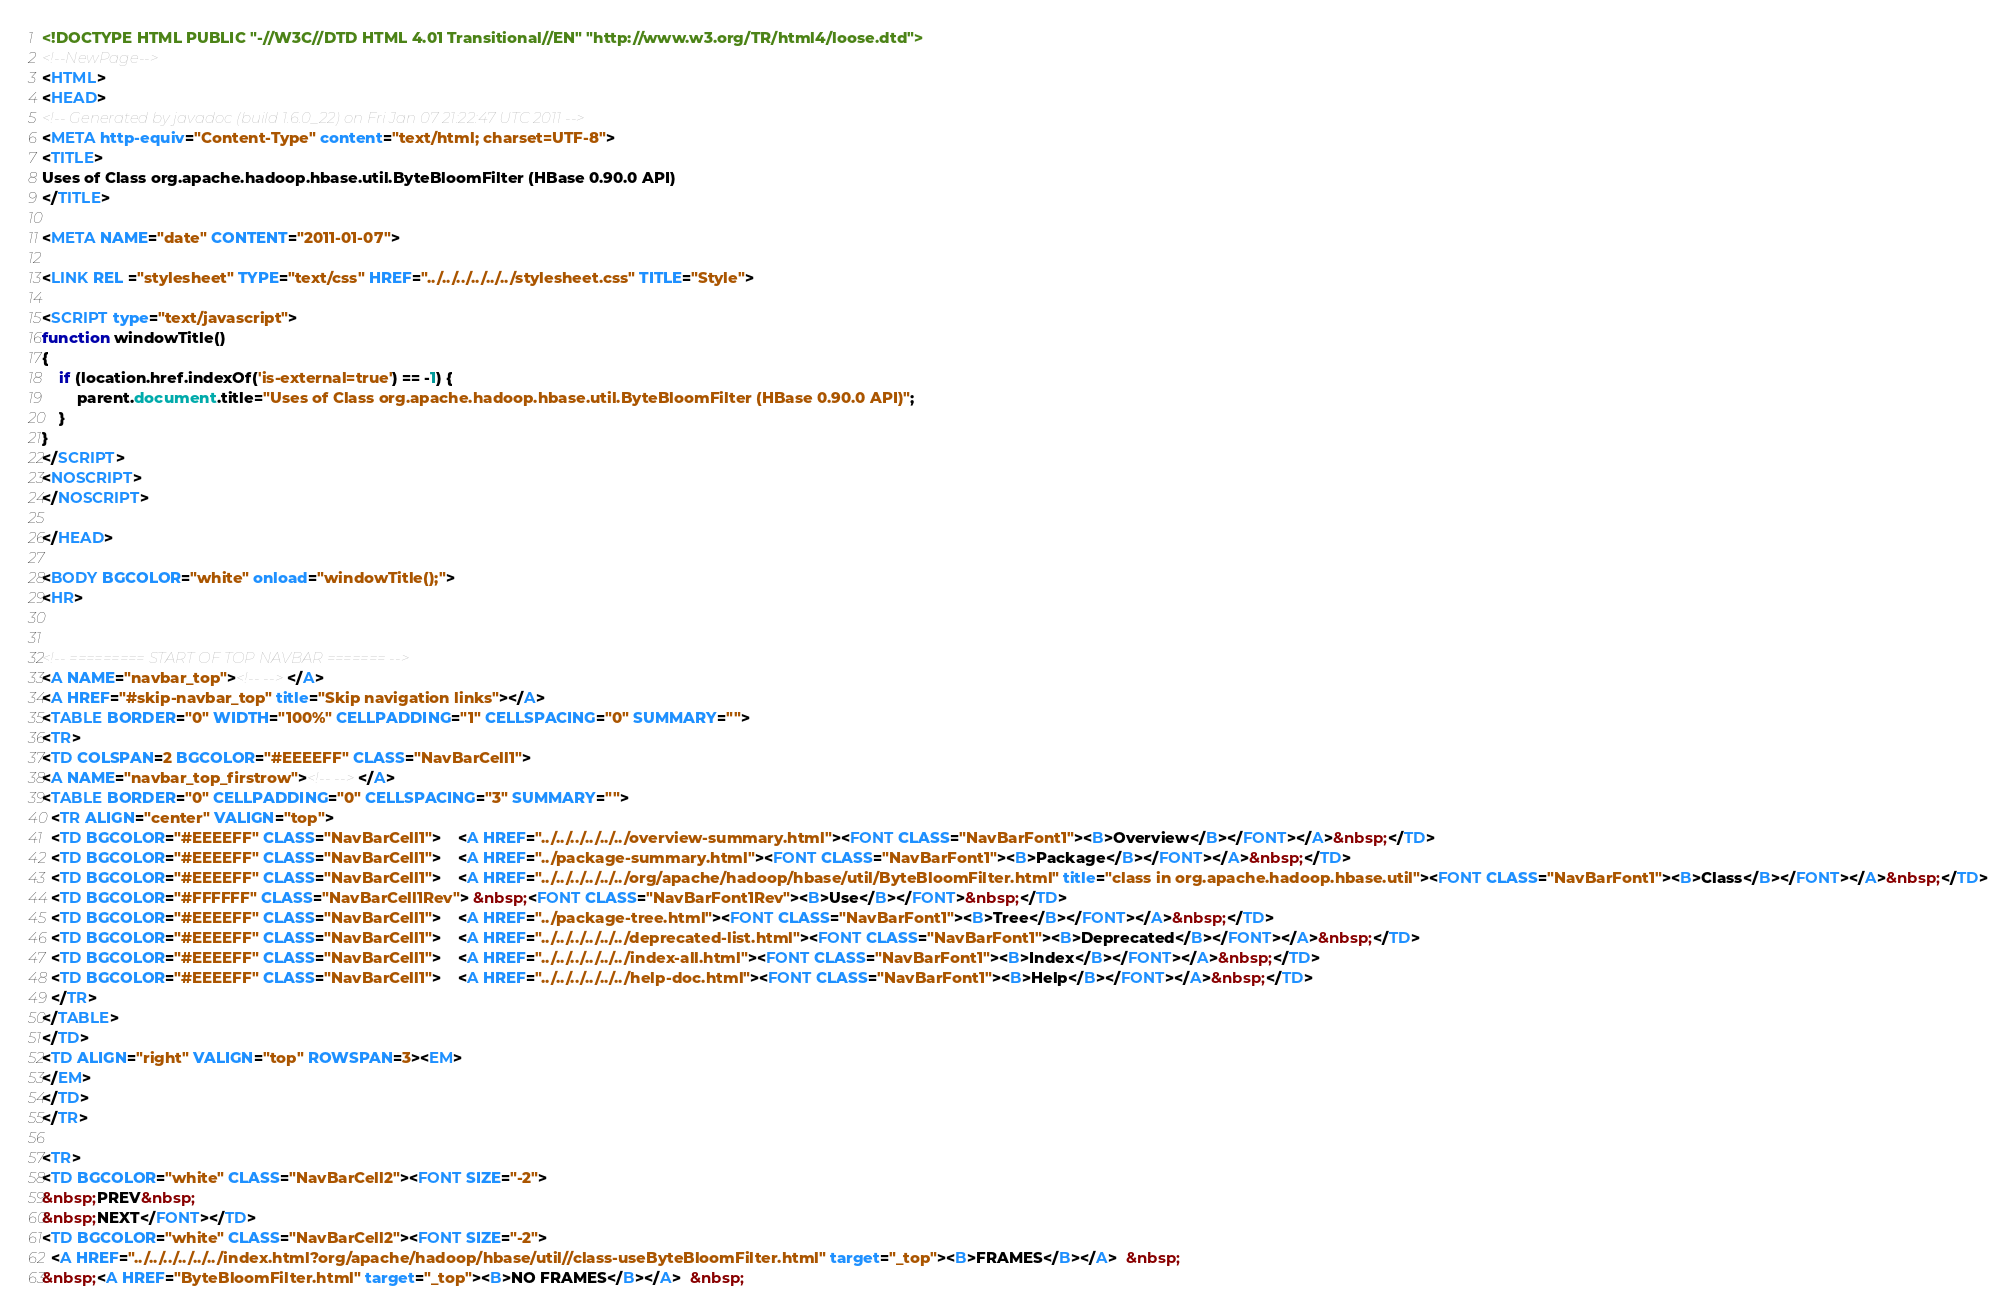Convert code to text. <code><loc_0><loc_0><loc_500><loc_500><_HTML_><!DOCTYPE HTML PUBLIC "-//W3C//DTD HTML 4.01 Transitional//EN" "http://www.w3.org/TR/html4/loose.dtd">
<!--NewPage-->
<HTML>
<HEAD>
<!-- Generated by javadoc (build 1.6.0_22) on Fri Jan 07 21:22:47 UTC 2011 -->
<META http-equiv="Content-Type" content="text/html; charset=UTF-8">
<TITLE>
Uses of Class org.apache.hadoop.hbase.util.ByteBloomFilter (HBase 0.90.0 API)
</TITLE>

<META NAME="date" CONTENT="2011-01-07">

<LINK REL ="stylesheet" TYPE="text/css" HREF="../../../../../../stylesheet.css" TITLE="Style">

<SCRIPT type="text/javascript">
function windowTitle()
{
    if (location.href.indexOf('is-external=true') == -1) {
        parent.document.title="Uses of Class org.apache.hadoop.hbase.util.ByteBloomFilter (HBase 0.90.0 API)";
    }
}
</SCRIPT>
<NOSCRIPT>
</NOSCRIPT>

</HEAD>

<BODY BGCOLOR="white" onload="windowTitle();">
<HR>


<!-- ========= START OF TOP NAVBAR ======= -->
<A NAME="navbar_top"><!-- --></A>
<A HREF="#skip-navbar_top" title="Skip navigation links"></A>
<TABLE BORDER="0" WIDTH="100%" CELLPADDING="1" CELLSPACING="0" SUMMARY="">
<TR>
<TD COLSPAN=2 BGCOLOR="#EEEEFF" CLASS="NavBarCell1">
<A NAME="navbar_top_firstrow"><!-- --></A>
<TABLE BORDER="0" CELLPADDING="0" CELLSPACING="3" SUMMARY="">
  <TR ALIGN="center" VALIGN="top">
  <TD BGCOLOR="#EEEEFF" CLASS="NavBarCell1">    <A HREF="../../../../../../overview-summary.html"><FONT CLASS="NavBarFont1"><B>Overview</B></FONT></A>&nbsp;</TD>
  <TD BGCOLOR="#EEEEFF" CLASS="NavBarCell1">    <A HREF="../package-summary.html"><FONT CLASS="NavBarFont1"><B>Package</B></FONT></A>&nbsp;</TD>
  <TD BGCOLOR="#EEEEFF" CLASS="NavBarCell1">    <A HREF="../../../../../../org/apache/hadoop/hbase/util/ByteBloomFilter.html" title="class in org.apache.hadoop.hbase.util"><FONT CLASS="NavBarFont1"><B>Class</B></FONT></A>&nbsp;</TD>
  <TD BGCOLOR="#FFFFFF" CLASS="NavBarCell1Rev"> &nbsp;<FONT CLASS="NavBarFont1Rev"><B>Use</B></FONT>&nbsp;</TD>
  <TD BGCOLOR="#EEEEFF" CLASS="NavBarCell1">    <A HREF="../package-tree.html"><FONT CLASS="NavBarFont1"><B>Tree</B></FONT></A>&nbsp;</TD>
  <TD BGCOLOR="#EEEEFF" CLASS="NavBarCell1">    <A HREF="../../../../../../deprecated-list.html"><FONT CLASS="NavBarFont1"><B>Deprecated</B></FONT></A>&nbsp;</TD>
  <TD BGCOLOR="#EEEEFF" CLASS="NavBarCell1">    <A HREF="../../../../../../index-all.html"><FONT CLASS="NavBarFont1"><B>Index</B></FONT></A>&nbsp;</TD>
  <TD BGCOLOR="#EEEEFF" CLASS="NavBarCell1">    <A HREF="../../../../../../help-doc.html"><FONT CLASS="NavBarFont1"><B>Help</B></FONT></A>&nbsp;</TD>
  </TR>
</TABLE>
</TD>
<TD ALIGN="right" VALIGN="top" ROWSPAN=3><EM>
</EM>
</TD>
</TR>

<TR>
<TD BGCOLOR="white" CLASS="NavBarCell2"><FONT SIZE="-2">
&nbsp;PREV&nbsp;
&nbsp;NEXT</FONT></TD>
<TD BGCOLOR="white" CLASS="NavBarCell2"><FONT SIZE="-2">
  <A HREF="../../../../../../index.html?org/apache/hadoop/hbase/util//class-useByteBloomFilter.html" target="_top"><B>FRAMES</B></A>  &nbsp;
&nbsp;<A HREF="ByteBloomFilter.html" target="_top"><B>NO FRAMES</B></A>  &nbsp;</code> 